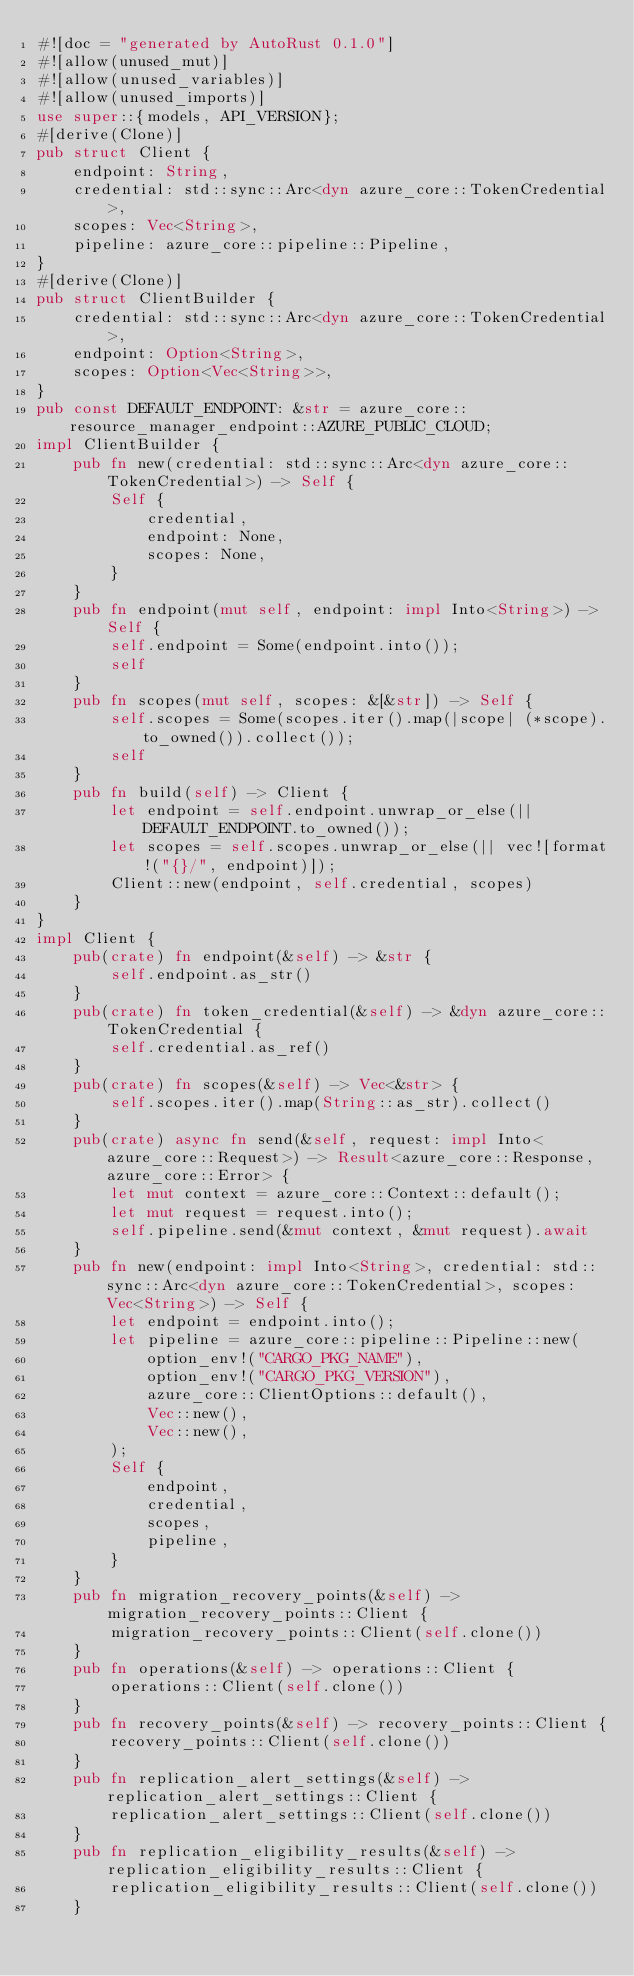<code> <loc_0><loc_0><loc_500><loc_500><_Rust_>#![doc = "generated by AutoRust 0.1.0"]
#![allow(unused_mut)]
#![allow(unused_variables)]
#![allow(unused_imports)]
use super::{models, API_VERSION};
#[derive(Clone)]
pub struct Client {
    endpoint: String,
    credential: std::sync::Arc<dyn azure_core::TokenCredential>,
    scopes: Vec<String>,
    pipeline: azure_core::pipeline::Pipeline,
}
#[derive(Clone)]
pub struct ClientBuilder {
    credential: std::sync::Arc<dyn azure_core::TokenCredential>,
    endpoint: Option<String>,
    scopes: Option<Vec<String>>,
}
pub const DEFAULT_ENDPOINT: &str = azure_core::resource_manager_endpoint::AZURE_PUBLIC_CLOUD;
impl ClientBuilder {
    pub fn new(credential: std::sync::Arc<dyn azure_core::TokenCredential>) -> Self {
        Self {
            credential,
            endpoint: None,
            scopes: None,
        }
    }
    pub fn endpoint(mut self, endpoint: impl Into<String>) -> Self {
        self.endpoint = Some(endpoint.into());
        self
    }
    pub fn scopes(mut self, scopes: &[&str]) -> Self {
        self.scopes = Some(scopes.iter().map(|scope| (*scope).to_owned()).collect());
        self
    }
    pub fn build(self) -> Client {
        let endpoint = self.endpoint.unwrap_or_else(|| DEFAULT_ENDPOINT.to_owned());
        let scopes = self.scopes.unwrap_or_else(|| vec![format!("{}/", endpoint)]);
        Client::new(endpoint, self.credential, scopes)
    }
}
impl Client {
    pub(crate) fn endpoint(&self) -> &str {
        self.endpoint.as_str()
    }
    pub(crate) fn token_credential(&self) -> &dyn azure_core::TokenCredential {
        self.credential.as_ref()
    }
    pub(crate) fn scopes(&self) -> Vec<&str> {
        self.scopes.iter().map(String::as_str).collect()
    }
    pub(crate) async fn send(&self, request: impl Into<azure_core::Request>) -> Result<azure_core::Response, azure_core::Error> {
        let mut context = azure_core::Context::default();
        let mut request = request.into();
        self.pipeline.send(&mut context, &mut request).await
    }
    pub fn new(endpoint: impl Into<String>, credential: std::sync::Arc<dyn azure_core::TokenCredential>, scopes: Vec<String>) -> Self {
        let endpoint = endpoint.into();
        let pipeline = azure_core::pipeline::Pipeline::new(
            option_env!("CARGO_PKG_NAME"),
            option_env!("CARGO_PKG_VERSION"),
            azure_core::ClientOptions::default(),
            Vec::new(),
            Vec::new(),
        );
        Self {
            endpoint,
            credential,
            scopes,
            pipeline,
        }
    }
    pub fn migration_recovery_points(&self) -> migration_recovery_points::Client {
        migration_recovery_points::Client(self.clone())
    }
    pub fn operations(&self) -> operations::Client {
        operations::Client(self.clone())
    }
    pub fn recovery_points(&self) -> recovery_points::Client {
        recovery_points::Client(self.clone())
    }
    pub fn replication_alert_settings(&self) -> replication_alert_settings::Client {
        replication_alert_settings::Client(self.clone())
    }
    pub fn replication_eligibility_results(&self) -> replication_eligibility_results::Client {
        replication_eligibility_results::Client(self.clone())
    }</code> 